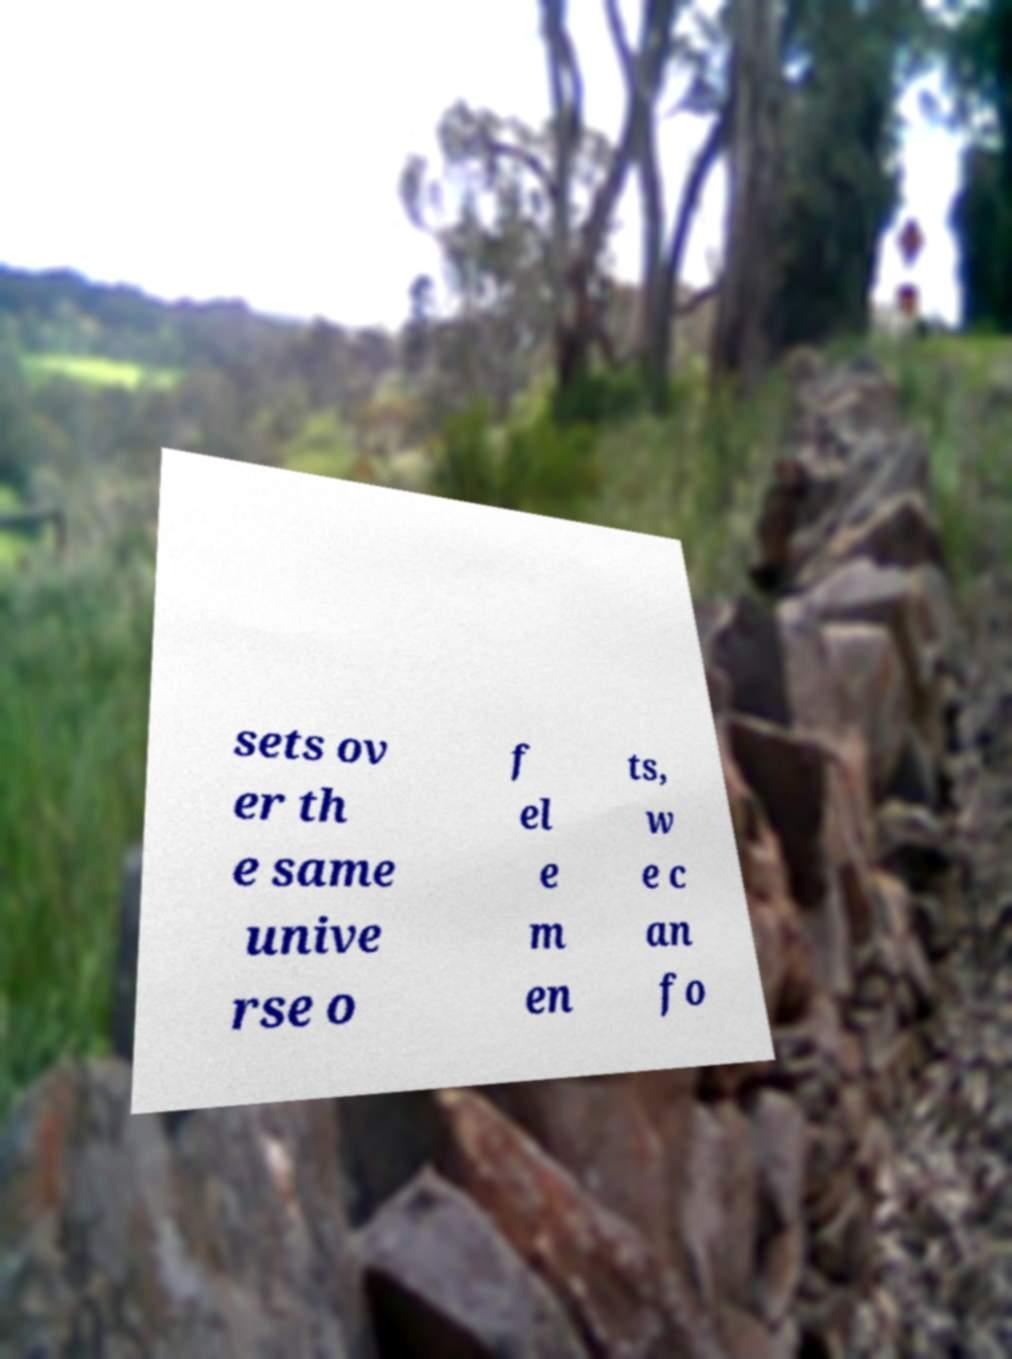What messages or text are displayed in this image? I need them in a readable, typed format. sets ov er th e same unive rse o f el e m en ts, w e c an fo 